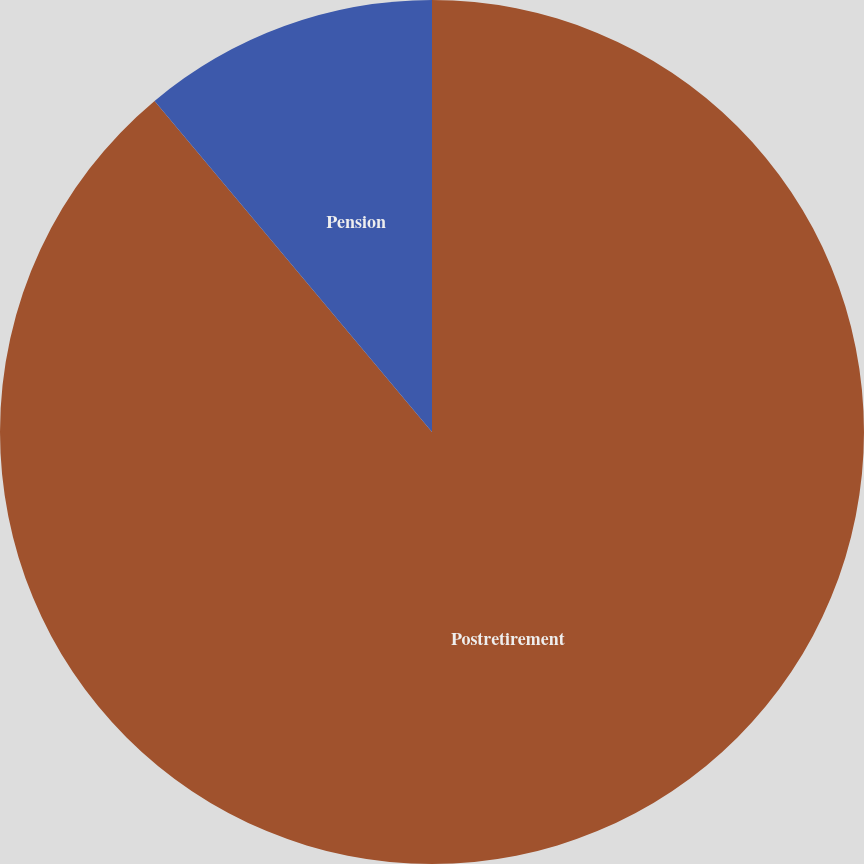Convert chart to OTSL. <chart><loc_0><loc_0><loc_500><loc_500><pie_chart><fcel>Postretirement<fcel>Pension<nl><fcel>88.9%<fcel>11.1%<nl></chart> 